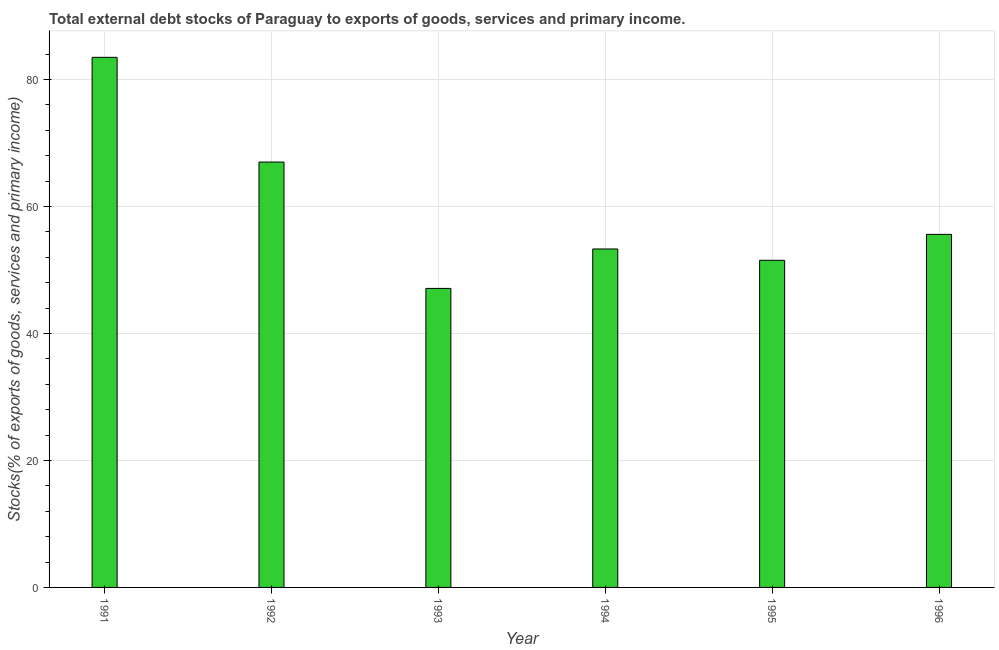Does the graph contain grids?
Provide a succinct answer. Yes. What is the title of the graph?
Offer a very short reply. Total external debt stocks of Paraguay to exports of goods, services and primary income. What is the label or title of the Y-axis?
Your response must be concise. Stocks(% of exports of goods, services and primary income). What is the external debt stocks in 1992?
Give a very brief answer. 67. Across all years, what is the maximum external debt stocks?
Provide a short and direct response. 83.49. Across all years, what is the minimum external debt stocks?
Ensure brevity in your answer.  47.09. In which year was the external debt stocks maximum?
Ensure brevity in your answer.  1991. In which year was the external debt stocks minimum?
Provide a succinct answer. 1993. What is the sum of the external debt stocks?
Make the answer very short. 358.02. What is the difference between the external debt stocks in 1991 and 1992?
Your response must be concise. 16.49. What is the average external debt stocks per year?
Provide a short and direct response. 59.67. What is the median external debt stocks?
Offer a terse response. 54.46. In how many years, is the external debt stocks greater than 80 %?
Keep it short and to the point. 1. What is the ratio of the external debt stocks in 1991 to that in 1992?
Provide a short and direct response. 1.25. Is the difference between the external debt stocks in 1995 and 1996 greater than the difference between any two years?
Keep it short and to the point. No. What is the difference between the highest and the second highest external debt stocks?
Give a very brief answer. 16.49. What is the difference between the highest and the lowest external debt stocks?
Your answer should be very brief. 36.4. In how many years, is the external debt stocks greater than the average external debt stocks taken over all years?
Provide a succinct answer. 2. How many bars are there?
Provide a succinct answer. 6. How many years are there in the graph?
Keep it short and to the point. 6. What is the Stocks(% of exports of goods, services and primary income) in 1991?
Offer a terse response. 83.49. What is the Stocks(% of exports of goods, services and primary income) of 1992?
Make the answer very short. 67. What is the Stocks(% of exports of goods, services and primary income) in 1993?
Keep it short and to the point. 47.09. What is the Stocks(% of exports of goods, services and primary income) of 1994?
Offer a terse response. 53.31. What is the Stocks(% of exports of goods, services and primary income) in 1995?
Your response must be concise. 51.52. What is the Stocks(% of exports of goods, services and primary income) of 1996?
Your answer should be very brief. 55.61. What is the difference between the Stocks(% of exports of goods, services and primary income) in 1991 and 1992?
Your answer should be compact. 16.49. What is the difference between the Stocks(% of exports of goods, services and primary income) in 1991 and 1993?
Your answer should be compact. 36.4. What is the difference between the Stocks(% of exports of goods, services and primary income) in 1991 and 1994?
Your response must be concise. 30.18. What is the difference between the Stocks(% of exports of goods, services and primary income) in 1991 and 1995?
Make the answer very short. 31.97. What is the difference between the Stocks(% of exports of goods, services and primary income) in 1991 and 1996?
Provide a succinct answer. 27.88. What is the difference between the Stocks(% of exports of goods, services and primary income) in 1992 and 1993?
Ensure brevity in your answer.  19.9. What is the difference between the Stocks(% of exports of goods, services and primary income) in 1992 and 1994?
Your response must be concise. 13.69. What is the difference between the Stocks(% of exports of goods, services and primary income) in 1992 and 1995?
Your answer should be very brief. 15.47. What is the difference between the Stocks(% of exports of goods, services and primary income) in 1992 and 1996?
Offer a very short reply. 11.39. What is the difference between the Stocks(% of exports of goods, services and primary income) in 1993 and 1994?
Provide a succinct answer. -6.21. What is the difference between the Stocks(% of exports of goods, services and primary income) in 1993 and 1995?
Your answer should be very brief. -4.43. What is the difference between the Stocks(% of exports of goods, services and primary income) in 1993 and 1996?
Ensure brevity in your answer.  -8.51. What is the difference between the Stocks(% of exports of goods, services and primary income) in 1994 and 1995?
Your response must be concise. 1.78. What is the difference between the Stocks(% of exports of goods, services and primary income) in 1994 and 1996?
Offer a terse response. -2.3. What is the difference between the Stocks(% of exports of goods, services and primary income) in 1995 and 1996?
Your response must be concise. -4.08. What is the ratio of the Stocks(% of exports of goods, services and primary income) in 1991 to that in 1992?
Your answer should be very brief. 1.25. What is the ratio of the Stocks(% of exports of goods, services and primary income) in 1991 to that in 1993?
Give a very brief answer. 1.77. What is the ratio of the Stocks(% of exports of goods, services and primary income) in 1991 to that in 1994?
Keep it short and to the point. 1.57. What is the ratio of the Stocks(% of exports of goods, services and primary income) in 1991 to that in 1995?
Provide a succinct answer. 1.62. What is the ratio of the Stocks(% of exports of goods, services and primary income) in 1991 to that in 1996?
Offer a very short reply. 1.5. What is the ratio of the Stocks(% of exports of goods, services and primary income) in 1992 to that in 1993?
Make the answer very short. 1.42. What is the ratio of the Stocks(% of exports of goods, services and primary income) in 1992 to that in 1994?
Offer a very short reply. 1.26. What is the ratio of the Stocks(% of exports of goods, services and primary income) in 1992 to that in 1996?
Make the answer very short. 1.21. What is the ratio of the Stocks(% of exports of goods, services and primary income) in 1993 to that in 1994?
Your response must be concise. 0.88. What is the ratio of the Stocks(% of exports of goods, services and primary income) in 1993 to that in 1995?
Your response must be concise. 0.91. What is the ratio of the Stocks(% of exports of goods, services and primary income) in 1993 to that in 1996?
Keep it short and to the point. 0.85. What is the ratio of the Stocks(% of exports of goods, services and primary income) in 1994 to that in 1995?
Offer a terse response. 1.03. What is the ratio of the Stocks(% of exports of goods, services and primary income) in 1994 to that in 1996?
Ensure brevity in your answer.  0.96. What is the ratio of the Stocks(% of exports of goods, services and primary income) in 1995 to that in 1996?
Your answer should be compact. 0.93. 